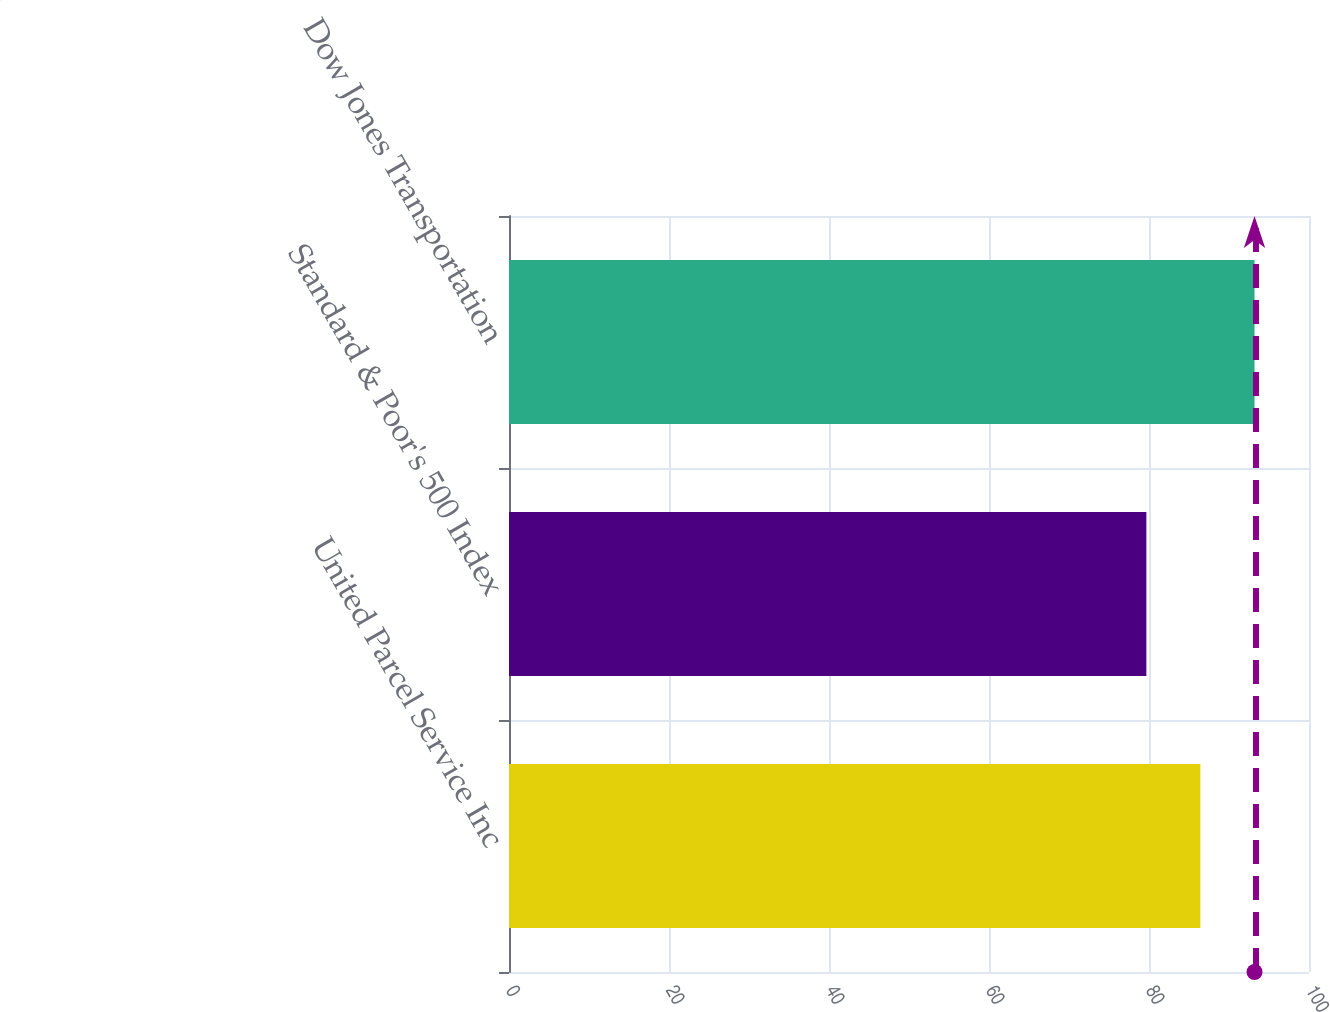Convert chart to OTSL. <chart><loc_0><loc_0><loc_500><loc_500><bar_chart><fcel>United Parcel Service Inc<fcel>Standard & Poor's 500 Index<fcel>Dow Jones Transportation<nl><fcel>86.42<fcel>79.67<fcel>93.19<nl></chart> 